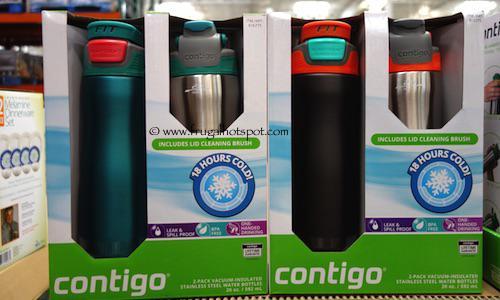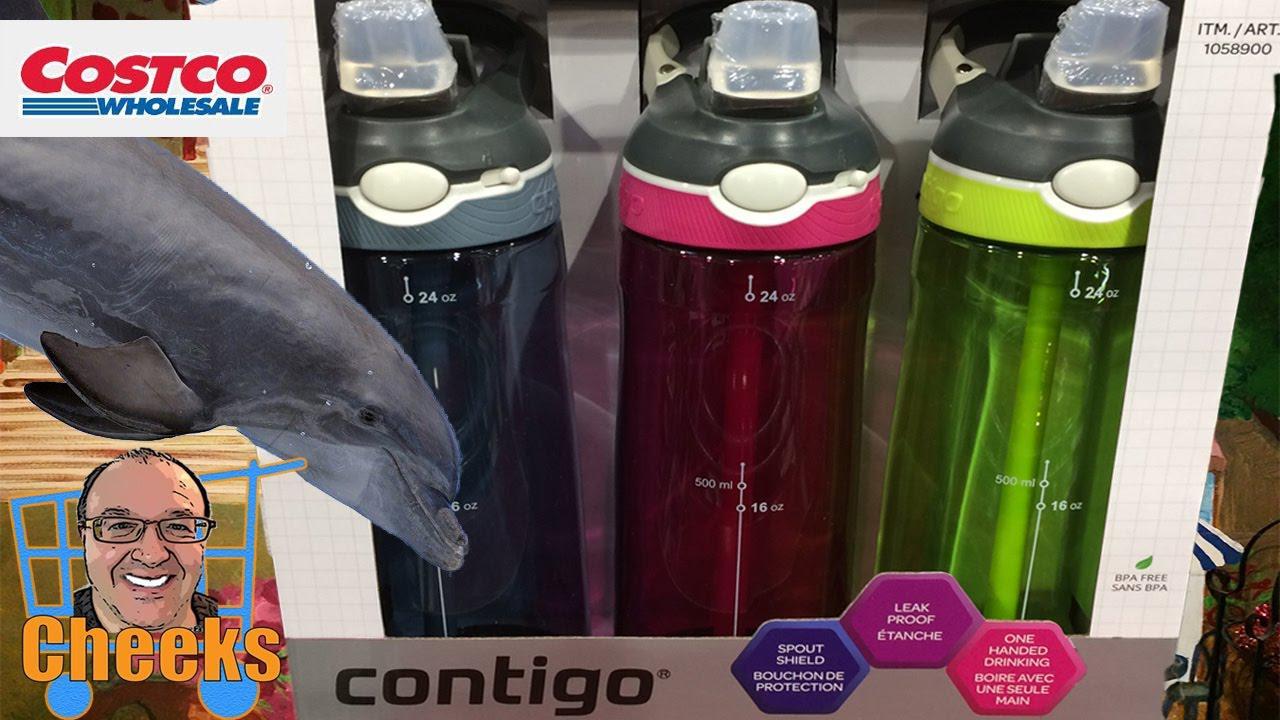The first image is the image on the left, the second image is the image on the right. Analyze the images presented: Is the assertion "A package showing three different colors of water bottles features a trio of blue, violet and hot pink hexagon shapes on the bottom front of the box." valid? Answer yes or no. Yes. The first image is the image on the left, the second image is the image on the right. Assess this claim about the two images: "A stainless steel water bottle is next to a green water bottle.". Correct or not? Answer yes or no. Yes. 